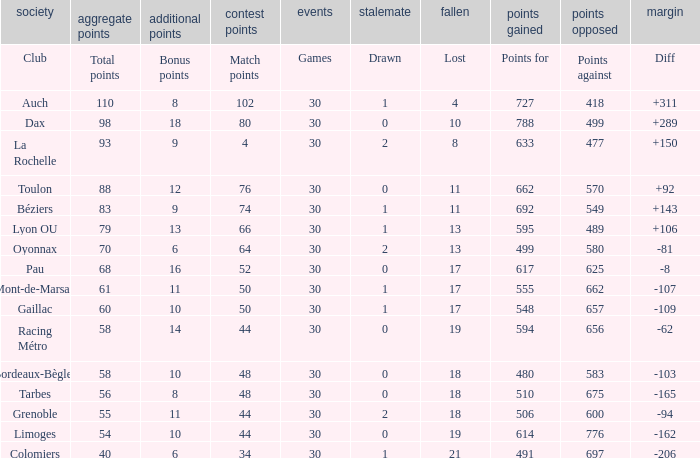How many bonus points did the Colomiers earn? 6.0. 